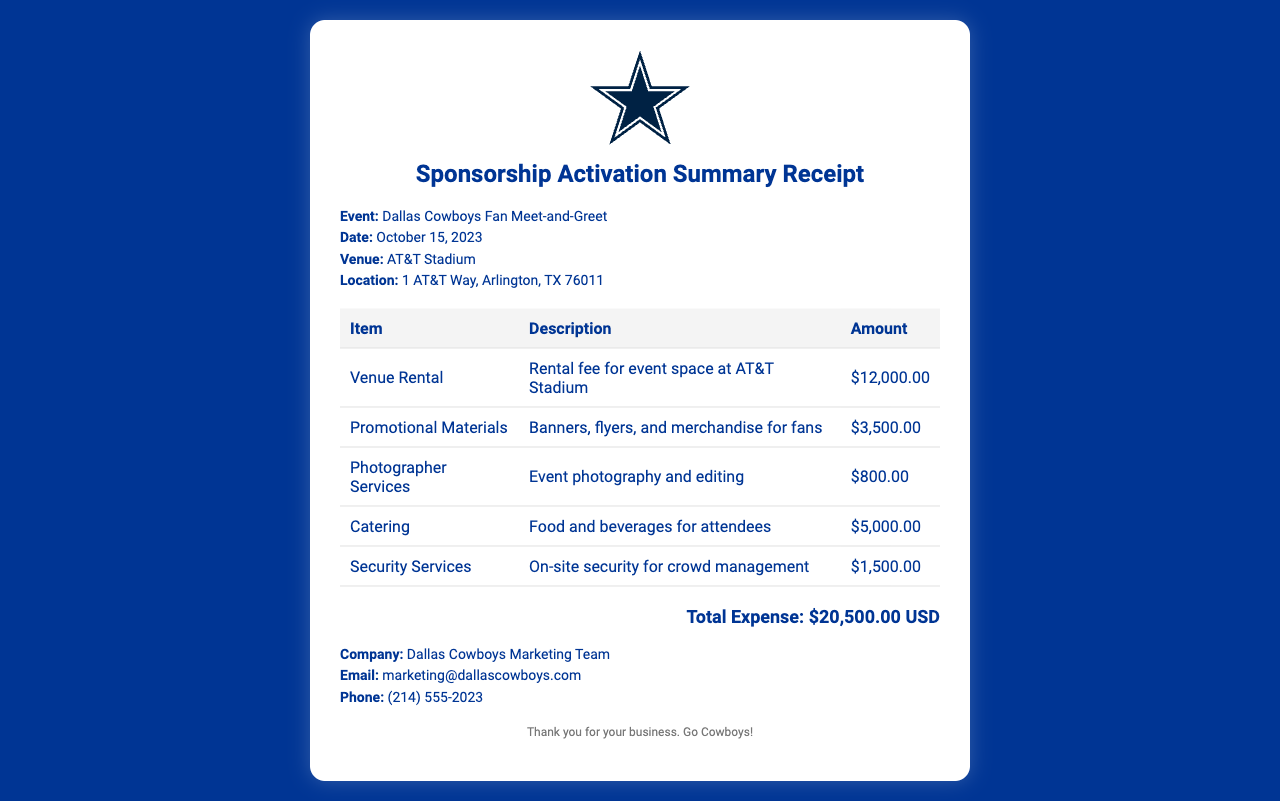What is the event date? The event date is specified in the document as October 15, 2023.
Answer: October 15, 2023 What is the venue for the event? The venue for the event is mentioned in the document.
Answer: AT&T Stadium How much was spent on promotional materials? The amount spent on promotional materials is detailed in the expense table.
Answer: $3,500.00 What is the total expense for the event? The total expense is calculated by summing up all individual expenses listed in the document.
Answer: $20,500.00 USD What type of catering services were included? The document notes "Food and beverages for attendees" as the catering services provided.
Answer: Food and beverages How much was allocated for security services? The amount for security services is listed in the expense table.
Answer: $1,500.00 Who is the contact email for the marketing team? The contact email for the Dallas Cowboys Marketing Team is provided in the document.
Answer: marketing@dallascowboys.com What is the primary purpose of this receipt? The primary purpose of the receipt is to summarize expenses incurred during a promotional event.
Answer: Sponsorship Activation Summary How many items are listed in the expenses? The document lists various items with corresponding amounts totalled in a table format.
Answer: 5 items What is the main theme represented in the document? The main theme is to celebrate and summarize the expenses of a fan engagement event related to the organization.
Answer: Cowboys fan meet-and-greet 